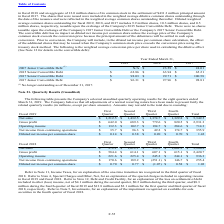According to Microchip Technology's financial document, Why might amounts may not add to the total? According to the financial document, due to rounding. The relevant text states: "share amounts). Amounts may not add to the total due to rounding:..." Also, What was the operating income in the first quarter? According to the financial document, 132.3 (in millions). The relevant text states: "Operating income $ 132.3 $ 102.7 $ 194.7 $ 284.6 $ 714.3..." Also, What was the total gross profit? According to the financial document, 2,931.3 (in millions). The relevant text states: "Gross profit $ 642.0 $ 689.3 $ 779.6 $ 820.5 $ 2,931.3..." Also, can you calculate: What was the change in the gross profit between the first and second quarter? Based on the calculation: 689.3-642.0, the result is 47.3 (in millions). This is based on the information: "Gross profit $ 642.0 $ 689.3 $ 779.6 $ 820.5 $ 2,931.3 Gross profit $ 642.0 $ 689.3 $ 779.6 $ 820.5 $ 2,931.3..." The key data points involved are: 642.0, 689.3. Also, can you calculate: What was the difference between the total net sales and gross profit? Based on the calculation: 5,349.5-2,931.3, the result is 2418.2 (in millions). This is based on the information: "Gross profit $ 642.0 $ 689.3 $ 779.6 $ 820.5 $ 2,931.3 t sales $ 1,212.5 $ 1,432.5 $ 1,374.7 $ 1,329.8 $ 5,349.5..." The key data points involved are: 2,931.3, 5,349.5. Also, can you calculate: What was the percentage change in the Operating income between the third and fourth quarter? To answer this question, I need to perform calculations using the financial data. The calculation is: (284.6-194.7)/194.7, which equals 46.17 (percentage). This is based on the information: "Operating income $ 132.3 $ 102.7 $ 194.7 $ 284.6 $ 714.3 Operating income $ 132.3 $ 102.7 $ 194.7 $ 284.6 $ 714.3..." The key data points involved are: 194.7, 284.6. 